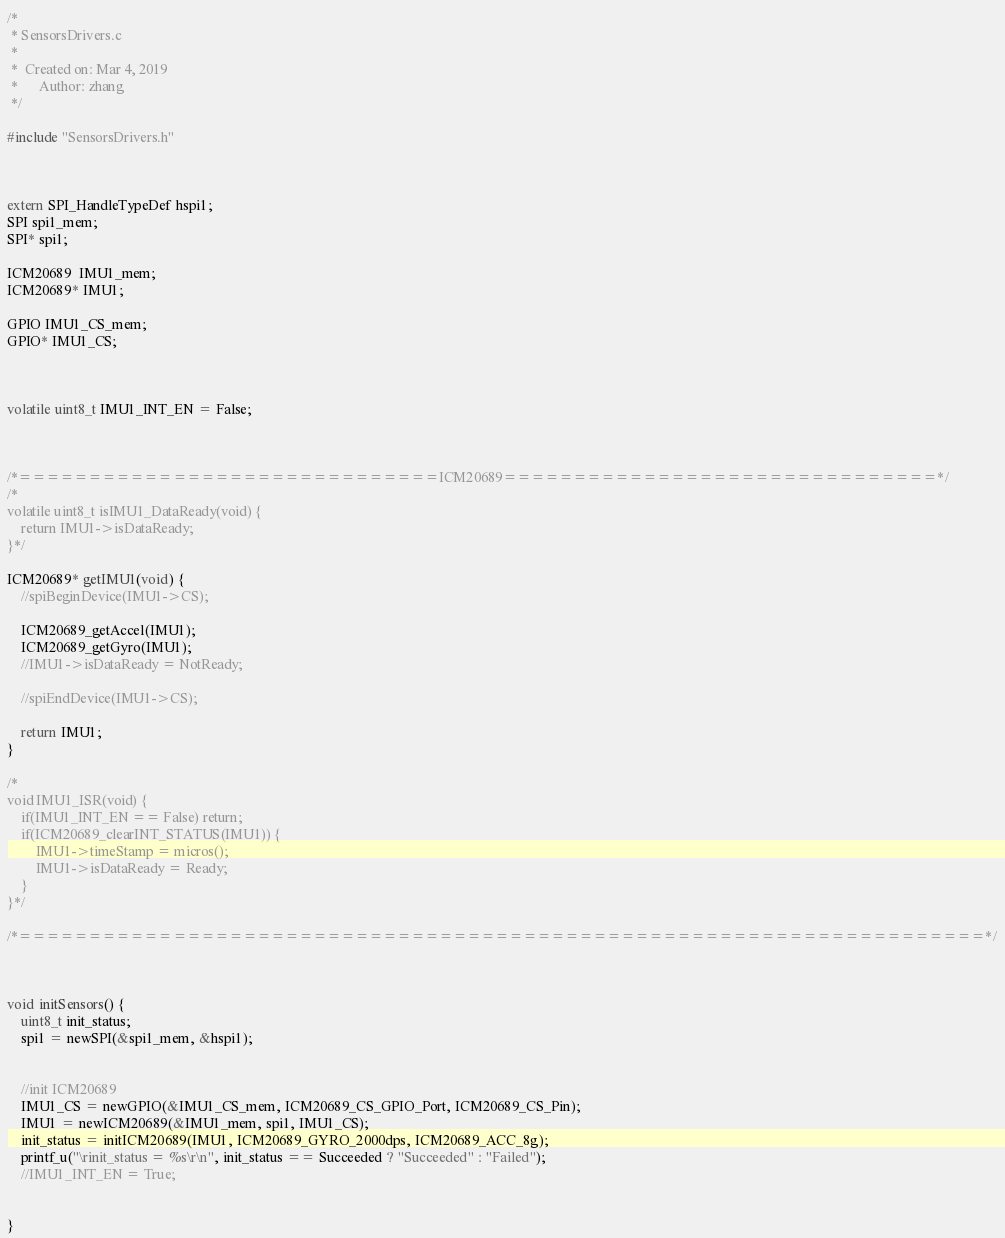<code> <loc_0><loc_0><loc_500><loc_500><_C_>/*
 * SensorsDrivers.c
 *
 *  Created on: Mar 4, 2019
 *      Author: zhang
 */

#include "SensorsDrivers.h"



extern SPI_HandleTypeDef hspi1;
SPI spi1_mem;
SPI* spi1;

ICM20689  IMU1_mem;
ICM20689* IMU1;

GPIO IMU1_CS_mem;
GPIO* IMU1_CS;



volatile uint8_t IMU1_INT_EN = False;



/*==============================ICM20689===============================*/
/*
volatile uint8_t isIMU1_DataReady(void) {
	return IMU1->isDataReady;
}*/

ICM20689* getIMU1(void) {
	//spiBeginDevice(IMU1->CS);

	ICM20689_getAccel(IMU1);
	ICM20689_getGyro(IMU1);
	//IMU1->isDataReady = NotReady;

	//spiEndDevice(IMU1->CS);

	return IMU1;
}

/*
void IMU1_ISR(void) {
	if(IMU1_INT_EN == False) return;
	if(ICM20689_clearINT_STATUS(IMU1)) {
		IMU1->timeStamp = micros();
		IMU1->isDataReady = Ready;
	}
}*/

/*=====================================================================*/



void initSensors() {
	uint8_t init_status;
	spi1 = newSPI(&spi1_mem, &hspi1);


	//init ICM20689
	IMU1_CS = newGPIO(&IMU1_CS_mem, ICM20689_CS_GPIO_Port, ICM20689_CS_Pin);
	IMU1 = newICM20689(&IMU1_mem, spi1, IMU1_CS);
	init_status = initICM20689(IMU1, ICM20689_GYRO_2000dps, ICM20689_ACC_8g);
	printf_u("\rinit_status = %s\r\n", init_status == Succeeded ? "Succeeded" : "Failed");
	//IMU1_INT_EN = True;


}
</code> 